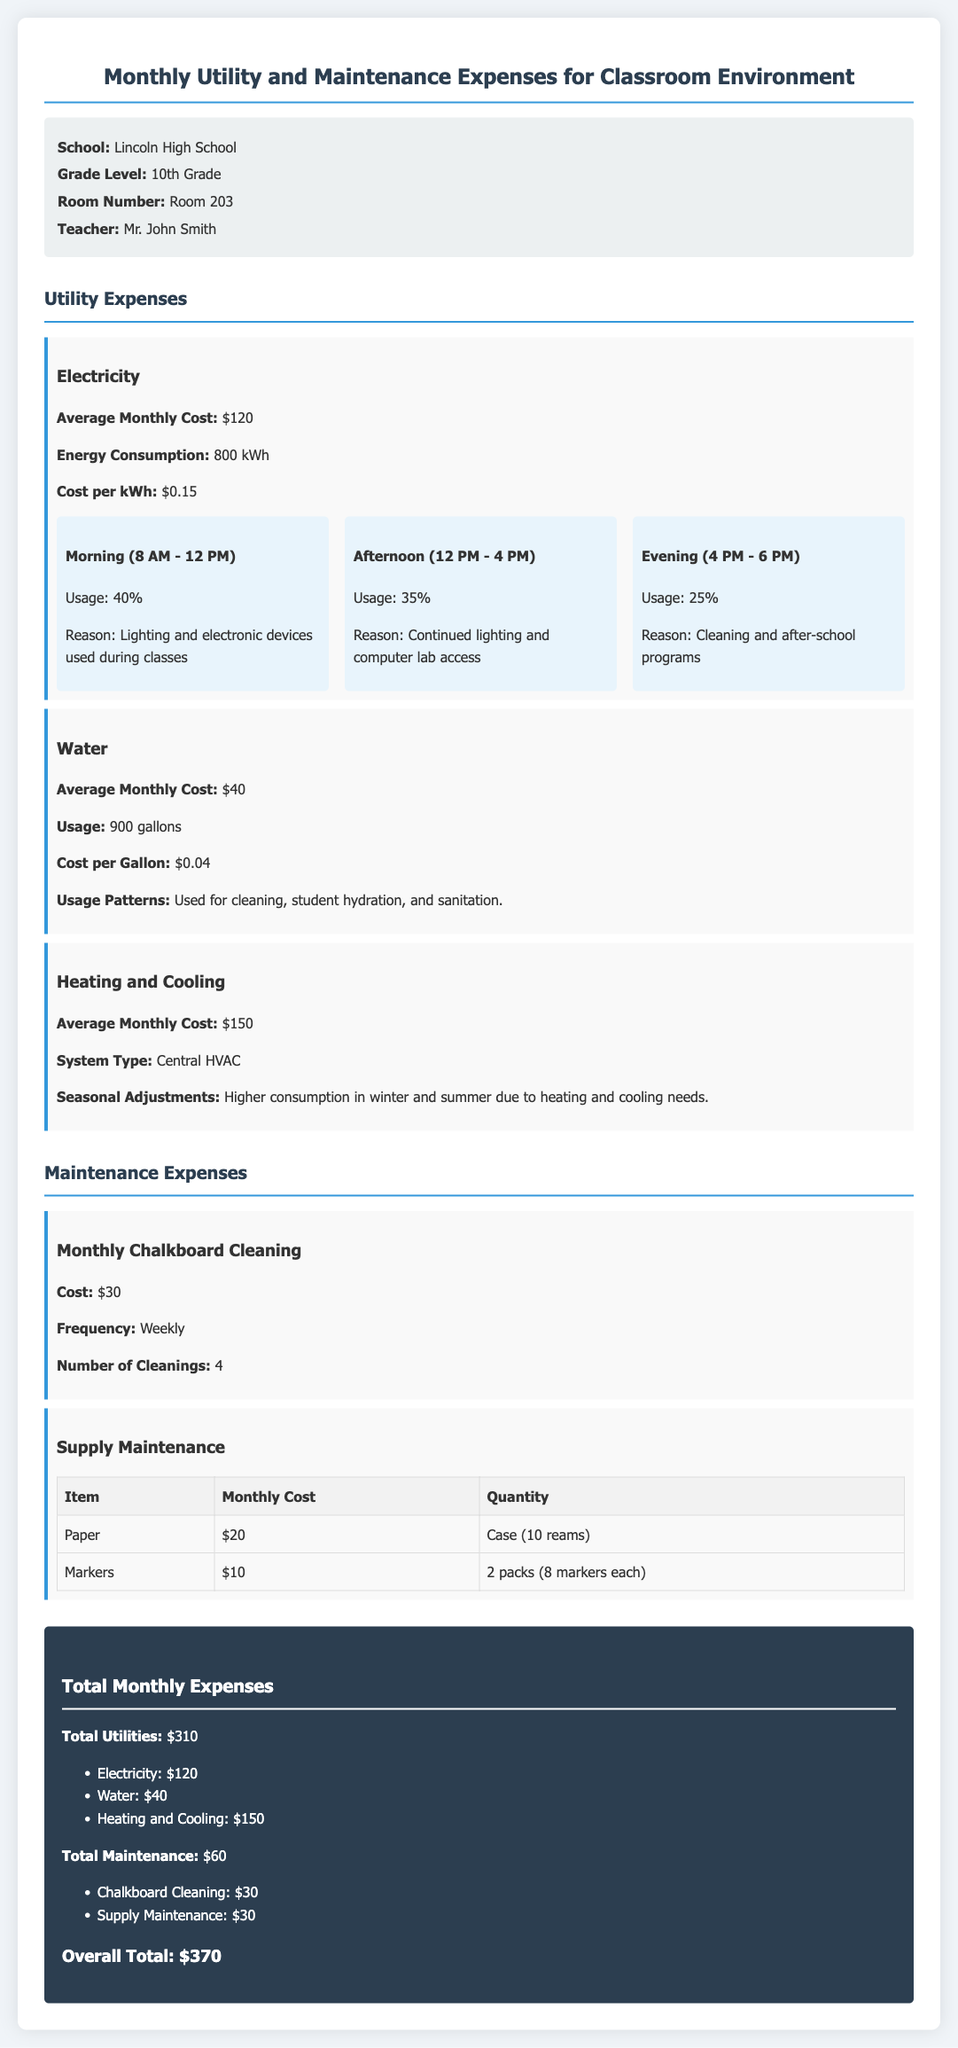What is the average monthly electricity cost? The average monthly electricity cost is listed under the utility expenses section.
Answer: $120 How many gallons of water are used monthly? The usage of water is detailed in the utility expenses section.
Answer: 900 gallons What is the main reason for energy use during morning hours? The reason for morning energy use is mentioned in the electricity expense section under consumption patterns.
Answer: Lighting and electronic devices used during classes What is the total cost of supply maintenance? The total cost can be found in the maintenance expenses section under supply maintenance.
Answer: $30 What type of heating system is used? The heating system type is listed in the utility expenses section.
Answer: Central HVAC What percentage of electricity is consumed in the afternoon? The percentage of electricity usage in the afternoon is provided in the patterns under electricity expense.
Answer: 35% How often is the chalkboard cleaned? The frequency of chalkboard cleaning is specified in the maintenance expenses section.
Answer: Weekly What is the overall total monthly expense? The overall total can be found in the total expenses section.
Answer: $370 